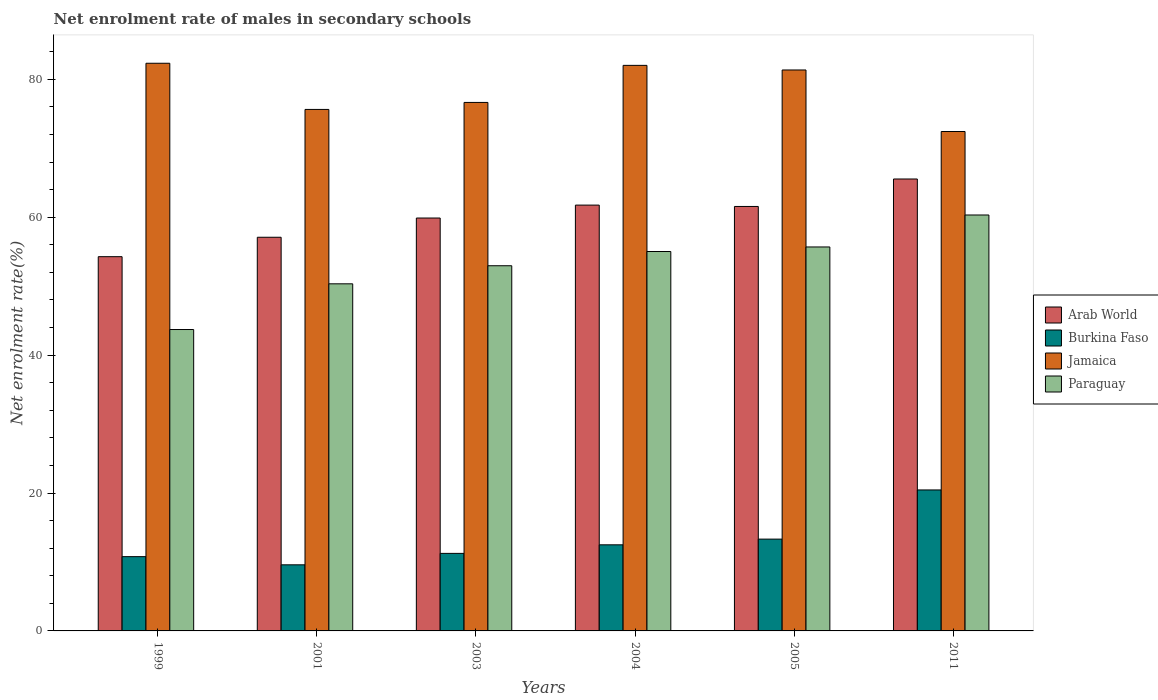Are the number of bars per tick equal to the number of legend labels?
Offer a very short reply. Yes. Are the number of bars on each tick of the X-axis equal?
Keep it short and to the point. Yes. How many bars are there on the 2nd tick from the right?
Ensure brevity in your answer.  4. What is the label of the 6th group of bars from the left?
Your answer should be very brief. 2011. What is the net enrolment rate of males in secondary schools in Burkina Faso in 2011?
Your response must be concise. 20.45. Across all years, what is the maximum net enrolment rate of males in secondary schools in Burkina Faso?
Your answer should be compact. 20.45. Across all years, what is the minimum net enrolment rate of males in secondary schools in Arab World?
Provide a short and direct response. 54.28. In which year was the net enrolment rate of males in secondary schools in Arab World minimum?
Provide a succinct answer. 1999. What is the total net enrolment rate of males in secondary schools in Arab World in the graph?
Your answer should be very brief. 360.13. What is the difference between the net enrolment rate of males in secondary schools in Paraguay in 2003 and that in 2004?
Keep it short and to the point. -2.06. What is the difference between the net enrolment rate of males in secondary schools in Burkina Faso in 2005 and the net enrolment rate of males in secondary schools in Arab World in 1999?
Offer a very short reply. -40.96. What is the average net enrolment rate of males in secondary schools in Arab World per year?
Offer a very short reply. 60.02. In the year 2001, what is the difference between the net enrolment rate of males in secondary schools in Arab World and net enrolment rate of males in secondary schools in Paraguay?
Your answer should be very brief. 6.75. In how many years, is the net enrolment rate of males in secondary schools in Paraguay greater than 36 %?
Your answer should be very brief. 6. What is the ratio of the net enrolment rate of males in secondary schools in Arab World in 2001 to that in 2011?
Provide a succinct answer. 0.87. Is the net enrolment rate of males in secondary schools in Paraguay in 2003 less than that in 2004?
Offer a terse response. Yes. What is the difference between the highest and the second highest net enrolment rate of males in secondary schools in Arab World?
Make the answer very short. 3.79. What is the difference between the highest and the lowest net enrolment rate of males in secondary schools in Jamaica?
Provide a succinct answer. 9.9. What does the 1st bar from the left in 2004 represents?
Provide a succinct answer. Arab World. What does the 1st bar from the right in 1999 represents?
Your response must be concise. Paraguay. How many years are there in the graph?
Give a very brief answer. 6. Where does the legend appear in the graph?
Provide a succinct answer. Center right. How are the legend labels stacked?
Make the answer very short. Vertical. What is the title of the graph?
Give a very brief answer. Net enrolment rate of males in secondary schools. What is the label or title of the X-axis?
Offer a terse response. Years. What is the label or title of the Y-axis?
Make the answer very short. Net enrolment rate(%). What is the Net enrolment rate(%) of Arab World in 1999?
Ensure brevity in your answer.  54.28. What is the Net enrolment rate(%) in Burkina Faso in 1999?
Your answer should be very brief. 10.77. What is the Net enrolment rate(%) in Jamaica in 1999?
Make the answer very short. 82.33. What is the Net enrolment rate(%) in Paraguay in 1999?
Keep it short and to the point. 43.71. What is the Net enrolment rate(%) of Arab World in 2001?
Your response must be concise. 57.1. What is the Net enrolment rate(%) in Burkina Faso in 2001?
Offer a terse response. 9.59. What is the Net enrolment rate(%) in Jamaica in 2001?
Your answer should be very brief. 75.63. What is the Net enrolment rate(%) of Paraguay in 2001?
Your response must be concise. 50.34. What is the Net enrolment rate(%) of Arab World in 2003?
Provide a succinct answer. 59.89. What is the Net enrolment rate(%) in Burkina Faso in 2003?
Provide a succinct answer. 11.25. What is the Net enrolment rate(%) of Jamaica in 2003?
Keep it short and to the point. 76.65. What is the Net enrolment rate(%) in Paraguay in 2003?
Give a very brief answer. 52.96. What is the Net enrolment rate(%) of Arab World in 2004?
Give a very brief answer. 61.76. What is the Net enrolment rate(%) in Burkina Faso in 2004?
Make the answer very short. 12.49. What is the Net enrolment rate(%) in Jamaica in 2004?
Give a very brief answer. 82.03. What is the Net enrolment rate(%) in Paraguay in 2004?
Your response must be concise. 55.03. What is the Net enrolment rate(%) of Arab World in 2005?
Ensure brevity in your answer.  61.56. What is the Net enrolment rate(%) in Burkina Faso in 2005?
Provide a short and direct response. 13.31. What is the Net enrolment rate(%) of Jamaica in 2005?
Make the answer very short. 81.36. What is the Net enrolment rate(%) of Paraguay in 2005?
Your answer should be very brief. 55.69. What is the Net enrolment rate(%) of Arab World in 2011?
Ensure brevity in your answer.  65.55. What is the Net enrolment rate(%) in Burkina Faso in 2011?
Your response must be concise. 20.45. What is the Net enrolment rate(%) of Jamaica in 2011?
Keep it short and to the point. 72.43. What is the Net enrolment rate(%) in Paraguay in 2011?
Provide a succinct answer. 60.33. Across all years, what is the maximum Net enrolment rate(%) of Arab World?
Ensure brevity in your answer.  65.55. Across all years, what is the maximum Net enrolment rate(%) in Burkina Faso?
Your answer should be compact. 20.45. Across all years, what is the maximum Net enrolment rate(%) in Jamaica?
Keep it short and to the point. 82.33. Across all years, what is the maximum Net enrolment rate(%) of Paraguay?
Give a very brief answer. 60.33. Across all years, what is the minimum Net enrolment rate(%) of Arab World?
Your answer should be very brief. 54.28. Across all years, what is the minimum Net enrolment rate(%) in Burkina Faso?
Your answer should be very brief. 9.59. Across all years, what is the minimum Net enrolment rate(%) of Jamaica?
Ensure brevity in your answer.  72.43. Across all years, what is the minimum Net enrolment rate(%) in Paraguay?
Give a very brief answer. 43.71. What is the total Net enrolment rate(%) in Arab World in the graph?
Offer a terse response. 360.13. What is the total Net enrolment rate(%) in Burkina Faso in the graph?
Keep it short and to the point. 77.85. What is the total Net enrolment rate(%) in Jamaica in the graph?
Ensure brevity in your answer.  470.44. What is the total Net enrolment rate(%) in Paraguay in the graph?
Provide a short and direct response. 318.06. What is the difference between the Net enrolment rate(%) in Arab World in 1999 and that in 2001?
Ensure brevity in your answer.  -2.82. What is the difference between the Net enrolment rate(%) in Burkina Faso in 1999 and that in 2001?
Keep it short and to the point. 1.19. What is the difference between the Net enrolment rate(%) of Jamaica in 1999 and that in 2001?
Provide a succinct answer. 6.7. What is the difference between the Net enrolment rate(%) in Paraguay in 1999 and that in 2001?
Ensure brevity in your answer.  -6.63. What is the difference between the Net enrolment rate(%) of Arab World in 1999 and that in 2003?
Your response must be concise. -5.61. What is the difference between the Net enrolment rate(%) of Burkina Faso in 1999 and that in 2003?
Give a very brief answer. -0.47. What is the difference between the Net enrolment rate(%) in Jamaica in 1999 and that in 2003?
Your answer should be compact. 5.68. What is the difference between the Net enrolment rate(%) of Paraguay in 1999 and that in 2003?
Provide a short and direct response. -9.25. What is the difference between the Net enrolment rate(%) in Arab World in 1999 and that in 2004?
Your response must be concise. -7.48. What is the difference between the Net enrolment rate(%) of Burkina Faso in 1999 and that in 2004?
Give a very brief answer. -1.71. What is the difference between the Net enrolment rate(%) of Jamaica in 1999 and that in 2004?
Ensure brevity in your answer.  0.31. What is the difference between the Net enrolment rate(%) in Paraguay in 1999 and that in 2004?
Ensure brevity in your answer.  -11.32. What is the difference between the Net enrolment rate(%) of Arab World in 1999 and that in 2005?
Make the answer very short. -7.28. What is the difference between the Net enrolment rate(%) in Burkina Faso in 1999 and that in 2005?
Give a very brief answer. -2.54. What is the difference between the Net enrolment rate(%) in Jamaica in 1999 and that in 2005?
Make the answer very short. 0.97. What is the difference between the Net enrolment rate(%) in Paraguay in 1999 and that in 2005?
Your answer should be compact. -11.98. What is the difference between the Net enrolment rate(%) of Arab World in 1999 and that in 2011?
Offer a very short reply. -11.27. What is the difference between the Net enrolment rate(%) of Burkina Faso in 1999 and that in 2011?
Provide a short and direct response. -9.67. What is the difference between the Net enrolment rate(%) in Jamaica in 1999 and that in 2011?
Give a very brief answer. 9.9. What is the difference between the Net enrolment rate(%) of Paraguay in 1999 and that in 2011?
Offer a terse response. -16.61. What is the difference between the Net enrolment rate(%) in Arab World in 2001 and that in 2003?
Provide a succinct answer. -2.79. What is the difference between the Net enrolment rate(%) of Burkina Faso in 2001 and that in 2003?
Keep it short and to the point. -1.66. What is the difference between the Net enrolment rate(%) in Jamaica in 2001 and that in 2003?
Make the answer very short. -1.02. What is the difference between the Net enrolment rate(%) of Paraguay in 2001 and that in 2003?
Your answer should be very brief. -2.62. What is the difference between the Net enrolment rate(%) of Arab World in 2001 and that in 2004?
Your answer should be very brief. -4.66. What is the difference between the Net enrolment rate(%) of Burkina Faso in 2001 and that in 2004?
Offer a terse response. -2.9. What is the difference between the Net enrolment rate(%) of Jamaica in 2001 and that in 2004?
Keep it short and to the point. -6.39. What is the difference between the Net enrolment rate(%) of Paraguay in 2001 and that in 2004?
Your answer should be very brief. -4.69. What is the difference between the Net enrolment rate(%) of Arab World in 2001 and that in 2005?
Give a very brief answer. -4.47. What is the difference between the Net enrolment rate(%) of Burkina Faso in 2001 and that in 2005?
Provide a short and direct response. -3.73. What is the difference between the Net enrolment rate(%) in Jamaica in 2001 and that in 2005?
Offer a very short reply. -5.72. What is the difference between the Net enrolment rate(%) of Paraguay in 2001 and that in 2005?
Your response must be concise. -5.35. What is the difference between the Net enrolment rate(%) of Arab World in 2001 and that in 2011?
Your response must be concise. -8.45. What is the difference between the Net enrolment rate(%) of Burkina Faso in 2001 and that in 2011?
Offer a very short reply. -10.86. What is the difference between the Net enrolment rate(%) in Jamaica in 2001 and that in 2011?
Provide a short and direct response. 3.2. What is the difference between the Net enrolment rate(%) in Paraguay in 2001 and that in 2011?
Make the answer very short. -9.98. What is the difference between the Net enrolment rate(%) in Arab World in 2003 and that in 2004?
Make the answer very short. -1.87. What is the difference between the Net enrolment rate(%) of Burkina Faso in 2003 and that in 2004?
Make the answer very short. -1.24. What is the difference between the Net enrolment rate(%) of Jamaica in 2003 and that in 2004?
Keep it short and to the point. -5.38. What is the difference between the Net enrolment rate(%) in Paraguay in 2003 and that in 2004?
Ensure brevity in your answer.  -2.06. What is the difference between the Net enrolment rate(%) in Arab World in 2003 and that in 2005?
Provide a succinct answer. -1.68. What is the difference between the Net enrolment rate(%) in Burkina Faso in 2003 and that in 2005?
Ensure brevity in your answer.  -2.07. What is the difference between the Net enrolment rate(%) of Jamaica in 2003 and that in 2005?
Make the answer very short. -4.71. What is the difference between the Net enrolment rate(%) in Paraguay in 2003 and that in 2005?
Your answer should be compact. -2.72. What is the difference between the Net enrolment rate(%) in Arab World in 2003 and that in 2011?
Offer a terse response. -5.66. What is the difference between the Net enrolment rate(%) of Burkina Faso in 2003 and that in 2011?
Make the answer very short. -9.2. What is the difference between the Net enrolment rate(%) of Jamaica in 2003 and that in 2011?
Your response must be concise. 4.22. What is the difference between the Net enrolment rate(%) of Paraguay in 2003 and that in 2011?
Offer a terse response. -7.36. What is the difference between the Net enrolment rate(%) of Arab World in 2004 and that in 2005?
Your response must be concise. 0.2. What is the difference between the Net enrolment rate(%) in Burkina Faso in 2004 and that in 2005?
Offer a very short reply. -0.83. What is the difference between the Net enrolment rate(%) in Jamaica in 2004 and that in 2005?
Make the answer very short. 0.67. What is the difference between the Net enrolment rate(%) in Paraguay in 2004 and that in 2005?
Your response must be concise. -0.66. What is the difference between the Net enrolment rate(%) of Arab World in 2004 and that in 2011?
Provide a short and direct response. -3.79. What is the difference between the Net enrolment rate(%) in Burkina Faso in 2004 and that in 2011?
Provide a succinct answer. -7.96. What is the difference between the Net enrolment rate(%) in Jamaica in 2004 and that in 2011?
Keep it short and to the point. 9.59. What is the difference between the Net enrolment rate(%) of Paraguay in 2004 and that in 2011?
Offer a terse response. -5.3. What is the difference between the Net enrolment rate(%) in Arab World in 2005 and that in 2011?
Your response must be concise. -3.98. What is the difference between the Net enrolment rate(%) in Burkina Faso in 2005 and that in 2011?
Provide a succinct answer. -7.13. What is the difference between the Net enrolment rate(%) in Jamaica in 2005 and that in 2011?
Your response must be concise. 8.93. What is the difference between the Net enrolment rate(%) in Paraguay in 2005 and that in 2011?
Your answer should be very brief. -4.64. What is the difference between the Net enrolment rate(%) of Arab World in 1999 and the Net enrolment rate(%) of Burkina Faso in 2001?
Your answer should be very brief. 44.69. What is the difference between the Net enrolment rate(%) of Arab World in 1999 and the Net enrolment rate(%) of Jamaica in 2001?
Keep it short and to the point. -21.35. What is the difference between the Net enrolment rate(%) in Arab World in 1999 and the Net enrolment rate(%) in Paraguay in 2001?
Offer a very short reply. 3.94. What is the difference between the Net enrolment rate(%) in Burkina Faso in 1999 and the Net enrolment rate(%) in Jamaica in 2001?
Provide a succinct answer. -64.86. What is the difference between the Net enrolment rate(%) of Burkina Faso in 1999 and the Net enrolment rate(%) of Paraguay in 2001?
Offer a very short reply. -39.57. What is the difference between the Net enrolment rate(%) of Jamaica in 1999 and the Net enrolment rate(%) of Paraguay in 2001?
Offer a terse response. 31.99. What is the difference between the Net enrolment rate(%) of Arab World in 1999 and the Net enrolment rate(%) of Burkina Faso in 2003?
Your answer should be very brief. 43.03. What is the difference between the Net enrolment rate(%) of Arab World in 1999 and the Net enrolment rate(%) of Jamaica in 2003?
Give a very brief answer. -22.37. What is the difference between the Net enrolment rate(%) of Arab World in 1999 and the Net enrolment rate(%) of Paraguay in 2003?
Your answer should be very brief. 1.32. What is the difference between the Net enrolment rate(%) of Burkina Faso in 1999 and the Net enrolment rate(%) of Jamaica in 2003?
Your response must be concise. -65.88. What is the difference between the Net enrolment rate(%) of Burkina Faso in 1999 and the Net enrolment rate(%) of Paraguay in 2003?
Your response must be concise. -42.19. What is the difference between the Net enrolment rate(%) in Jamaica in 1999 and the Net enrolment rate(%) in Paraguay in 2003?
Give a very brief answer. 29.37. What is the difference between the Net enrolment rate(%) of Arab World in 1999 and the Net enrolment rate(%) of Burkina Faso in 2004?
Keep it short and to the point. 41.79. What is the difference between the Net enrolment rate(%) of Arab World in 1999 and the Net enrolment rate(%) of Jamaica in 2004?
Keep it short and to the point. -27.75. What is the difference between the Net enrolment rate(%) in Arab World in 1999 and the Net enrolment rate(%) in Paraguay in 2004?
Offer a terse response. -0.75. What is the difference between the Net enrolment rate(%) in Burkina Faso in 1999 and the Net enrolment rate(%) in Jamaica in 2004?
Offer a very short reply. -71.25. What is the difference between the Net enrolment rate(%) of Burkina Faso in 1999 and the Net enrolment rate(%) of Paraguay in 2004?
Give a very brief answer. -44.26. What is the difference between the Net enrolment rate(%) in Jamaica in 1999 and the Net enrolment rate(%) in Paraguay in 2004?
Your answer should be compact. 27.3. What is the difference between the Net enrolment rate(%) in Arab World in 1999 and the Net enrolment rate(%) in Burkina Faso in 2005?
Make the answer very short. 40.96. What is the difference between the Net enrolment rate(%) of Arab World in 1999 and the Net enrolment rate(%) of Jamaica in 2005?
Provide a succinct answer. -27.08. What is the difference between the Net enrolment rate(%) of Arab World in 1999 and the Net enrolment rate(%) of Paraguay in 2005?
Give a very brief answer. -1.41. What is the difference between the Net enrolment rate(%) in Burkina Faso in 1999 and the Net enrolment rate(%) in Jamaica in 2005?
Provide a short and direct response. -70.59. What is the difference between the Net enrolment rate(%) in Burkina Faso in 1999 and the Net enrolment rate(%) in Paraguay in 2005?
Provide a succinct answer. -44.92. What is the difference between the Net enrolment rate(%) of Jamaica in 1999 and the Net enrolment rate(%) of Paraguay in 2005?
Your answer should be compact. 26.64. What is the difference between the Net enrolment rate(%) of Arab World in 1999 and the Net enrolment rate(%) of Burkina Faso in 2011?
Give a very brief answer. 33.83. What is the difference between the Net enrolment rate(%) of Arab World in 1999 and the Net enrolment rate(%) of Jamaica in 2011?
Provide a short and direct response. -18.15. What is the difference between the Net enrolment rate(%) in Arab World in 1999 and the Net enrolment rate(%) in Paraguay in 2011?
Offer a very short reply. -6.05. What is the difference between the Net enrolment rate(%) of Burkina Faso in 1999 and the Net enrolment rate(%) of Jamaica in 2011?
Give a very brief answer. -61.66. What is the difference between the Net enrolment rate(%) of Burkina Faso in 1999 and the Net enrolment rate(%) of Paraguay in 2011?
Provide a succinct answer. -49.55. What is the difference between the Net enrolment rate(%) of Jamaica in 1999 and the Net enrolment rate(%) of Paraguay in 2011?
Offer a terse response. 22.01. What is the difference between the Net enrolment rate(%) in Arab World in 2001 and the Net enrolment rate(%) in Burkina Faso in 2003?
Your response must be concise. 45.85. What is the difference between the Net enrolment rate(%) in Arab World in 2001 and the Net enrolment rate(%) in Jamaica in 2003?
Give a very brief answer. -19.55. What is the difference between the Net enrolment rate(%) in Arab World in 2001 and the Net enrolment rate(%) in Paraguay in 2003?
Ensure brevity in your answer.  4.13. What is the difference between the Net enrolment rate(%) in Burkina Faso in 2001 and the Net enrolment rate(%) in Jamaica in 2003?
Make the answer very short. -67.06. What is the difference between the Net enrolment rate(%) of Burkina Faso in 2001 and the Net enrolment rate(%) of Paraguay in 2003?
Ensure brevity in your answer.  -43.38. What is the difference between the Net enrolment rate(%) of Jamaica in 2001 and the Net enrolment rate(%) of Paraguay in 2003?
Offer a very short reply. 22.67. What is the difference between the Net enrolment rate(%) in Arab World in 2001 and the Net enrolment rate(%) in Burkina Faso in 2004?
Make the answer very short. 44.61. What is the difference between the Net enrolment rate(%) of Arab World in 2001 and the Net enrolment rate(%) of Jamaica in 2004?
Offer a very short reply. -24.93. What is the difference between the Net enrolment rate(%) of Arab World in 2001 and the Net enrolment rate(%) of Paraguay in 2004?
Provide a succinct answer. 2.07. What is the difference between the Net enrolment rate(%) of Burkina Faso in 2001 and the Net enrolment rate(%) of Jamaica in 2004?
Offer a very short reply. -72.44. What is the difference between the Net enrolment rate(%) of Burkina Faso in 2001 and the Net enrolment rate(%) of Paraguay in 2004?
Your answer should be compact. -45.44. What is the difference between the Net enrolment rate(%) of Jamaica in 2001 and the Net enrolment rate(%) of Paraguay in 2004?
Ensure brevity in your answer.  20.61. What is the difference between the Net enrolment rate(%) in Arab World in 2001 and the Net enrolment rate(%) in Burkina Faso in 2005?
Your answer should be compact. 43.78. What is the difference between the Net enrolment rate(%) in Arab World in 2001 and the Net enrolment rate(%) in Jamaica in 2005?
Your answer should be very brief. -24.26. What is the difference between the Net enrolment rate(%) in Arab World in 2001 and the Net enrolment rate(%) in Paraguay in 2005?
Keep it short and to the point. 1.41. What is the difference between the Net enrolment rate(%) in Burkina Faso in 2001 and the Net enrolment rate(%) in Jamaica in 2005?
Provide a short and direct response. -71.77. What is the difference between the Net enrolment rate(%) of Burkina Faso in 2001 and the Net enrolment rate(%) of Paraguay in 2005?
Make the answer very short. -46.1. What is the difference between the Net enrolment rate(%) of Jamaica in 2001 and the Net enrolment rate(%) of Paraguay in 2005?
Offer a very short reply. 19.95. What is the difference between the Net enrolment rate(%) in Arab World in 2001 and the Net enrolment rate(%) in Burkina Faso in 2011?
Ensure brevity in your answer.  36.65. What is the difference between the Net enrolment rate(%) of Arab World in 2001 and the Net enrolment rate(%) of Jamaica in 2011?
Make the answer very short. -15.34. What is the difference between the Net enrolment rate(%) in Arab World in 2001 and the Net enrolment rate(%) in Paraguay in 2011?
Offer a very short reply. -3.23. What is the difference between the Net enrolment rate(%) in Burkina Faso in 2001 and the Net enrolment rate(%) in Jamaica in 2011?
Give a very brief answer. -62.85. What is the difference between the Net enrolment rate(%) of Burkina Faso in 2001 and the Net enrolment rate(%) of Paraguay in 2011?
Offer a terse response. -50.74. What is the difference between the Net enrolment rate(%) in Jamaica in 2001 and the Net enrolment rate(%) in Paraguay in 2011?
Ensure brevity in your answer.  15.31. What is the difference between the Net enrolment rate(%) in Arab World in 2003 and the Net enrolment rate(%) in Burkina Faso in 2004?
Give a very brief answer. 47.4. What is the difference between the Net enrolment rate(%) in Arab World in 2003 and the Net enrolment rate(%) in Jamaica in 2004?
Keep it short and to the point. -22.14. What is the difference between the Net enrolment rate(%) in Arab World in 2003 and the Net enrolment rate(%) in Paraguay in 2004?
Make the answer very short. 4.86. What is the difference between the Net enrolment rate(%) of Burkina Faso in 2003 and the Net enrolment rate(%) of Jamaica in 2004?
Offer a very short reply. -70.78. What is the difference between the Net enrolment rate(%) of Burkina Faso in 2003 and the Net enrolment rate(%) of Paraguay in 2004?
Make the answer very short. -43.78. What is the difference between the Net enrolment rate(%) of Jamaica in 2003 and the Net enrolment rate(%) of Paraguay in 2004?
Offer a terse response. 21.62. What is the difference between the Net enrolment rate(%) of Arab World in 2003 and the Net enrolment rate(%) of Burkina Faso in 2005?
Your response must be concise. 46.57. What is the difference between the Net enrolment rate(%) of Arab World in 2003 and the Net enrolment rate(%) of Jamaica in 2005?
Ensure brevity in your answer.  -21.47. What is the difference between the Net enrolment rate(%) in Arab World in 2003 and the Net enrolment rate(%) in Paraguay in 2005?
Provide a succinct answer. 4.2. What is the difference between the Net enrolment rate(%) of Burkina Faso in 2003 and the Net enrolment rate(%) of Jamaica in 2005?
Keep it short and to the point. -70.11. What is the difference between the Net enrolment rate(%) in Burkina Faso in 2003 and the Net enrolment rate(%) in Paraguay in 2005?
Make the answer very short. -44.44. What is the difference between the Net enrolment rate(%) of Jamaica in 2003 and the Net enrolment rate(%) of Paraguay in 2005?
Provide a succinct answer. 20.96. What is the difference between the Net enrolment rate(%) of Arab World in 2003 and the Net enrolment rate(%) of Burkina Faso in 2011?
Offer a terse response. 39.44. What is the difference between the Net enrolment rate(%) in Arab World in 2003 and the Net enrolment rate(%) in Jamaica in 2011?
Ensure brevity in your answer.  -12.55. What is the difference between the Net enrolment rate(%) in Arab World in 2003 and the Net enrolment rate(%) in Paraguay in 2011?
Your response must be concise. -0.44. What is the difference between the Net enrolment rate(%) of Burkina Faso in 2003 and the Net enrolment rate(%) of Jamaica in 2011?
Provide a succinct answer. -61.19. What is the difference between the Net enrolment rate(%) of Burkina Faso in 2003 and the Net enrolment rate(%) of Paraguay in 2011?
Provide a short and direct response. -49.08. What is the difference between the Net enrolment rate(%) of Jamaica in 2003 and the Net enrolment rate(%) of Paraguay in 2011?
Provide a short and direct response. 16.33. What is the difference between the Net enrolment rate(%) in Arab World in 2004 and the Net enrolment rate(%) in Burkina Faso in 2005?
Provide a succinct answer. 48.44. What is the difference between the Net enrolment rate(%) in Arab World in 2004 and the Net enrolment rate(%) in Jamaica in 2005?
Keep it short and to the point. -19.6. What is the difference between the Net enrolment rate(%) in Arab World in 2004 and the Net enrolment rate(%) in Paraguay in 2005?
Provide a succinct answer. 6.07. What is the difference between the Net enrolment rate(%) in Burkina Faso in 2004 and the Net enrolment rate(%) in Jamaica in 2005?
Offer a very short reply. -68.87. What is the difference between the Net enrolment rate(%) in Burkina Faso in 2004 and the Net enrolment rate(%) in Paraguay in 2005?
Give a very brief answer. -43.2. What is the difference between the Net enrolment rate(%) in Jamaica in 2004 and the Net enrolment rate(%) in Paraguay in 2005?
Provide a succinct answer. 26.34. What is the difference between the Net enrolment rate(%) in Arab World in 2004 and the Net enrolment rate(%) in Burkina Faso in 2011?
Provide a short and direct response. 41.31. What is the difference between the Net enrolment rate(%) of Arab World in 2004 and the Net enrolment rate(%) of Jamaica in 2011?
Provide a succinct answer. -10.67. What is the difference between the Net enrolment rate(%) in Arab World in 2004 and the Net enrolment rate(%) in Paraguay in 2011?
Provide a short and direct response. 1.43. What is the difference between the Net enrolment rate(%) of Burkina Faso in 2004 and the Net enrolment rate(%) of Jamaica in 2011?
Keep it short and to the point. -59.95. What is the difference between the Net enrolment rate(%) in Burkina Faso in 2004 and the Net enrolment rate(%) in Paraguay in 2011?
Offer a terse response. -47.84. What is the difference between the Net enrolment rate(%) of Jamaica in 2004 and the Net enrolment rate(%) of Paraguay in 2011?
Your response must be concise. 21.7. What is the difference between the Net enrolment rate(%) in Arab World in 2005 and the Net enrolment rate(%) in Burkina Faso in 2011?
Keep it short and to the point. 41.12. What is the difference between the Net enrolment rate(%) in Arab World in 2005 and the Net enrolment rate(%) in Jamaica in 2011?
Offer a terse response. -10.87. What is the difference between the Net enrolment rate(%) of Arab World in 2005 and the Net enrolment rate(%) of Paraguay in 2011?
Your answer should be very brief. 1.24. What is the difference between the Net enrolment rate(%) of Burkina Faso in 2005 and the Net enrolment rate(%) of Jamaica in 2011?
Make the answer very short. -59.12. What is the difference between the Net enrolment rate(%) in Burkina Faso in 2005 and the Net enrolment rate(%) in Paraguay in 2011?
Your response must be concise. -47.01. What is the difference between the Net enrolment rate(%) of Jamaica in 2005 and the Net enrolment rate(%) of Paraguay in 2011?
Make the answer very short. 21.03. What is the average Net enrolment rate(%) in Arab World per year?
Your response must be concise. 60.02. What is the average Net enrolment rate(%) in Burkina Faso per year?
Offer a very short reply. 12.98. What is the average Net enrolment rate(%) in Jamaica per year?
Ensure brevity in your answer.  78.41. What is the average Net enrolment rate(%) in Paraguay per year?
Your answer should be compact. 53.01. In the year 1999, what is the difference between the Net enrolment rate(%) of Arab World and Net enrolment rate(%) of Burkina Faso?
Give a very brief answer. 43.51. In the year 1999, what is the difference between the Net enrolment rate(%) in Arab World and Net enrolment rate(%) in Jamaica?
Your response must be concise. -28.05. In the year 1999, what is the difference between the Net enrolment rate(%) of Arab World and Net enrolment rate(%) of Paraguay?
Your answer should be very brief. 10.57. In the year 1999, what is the difference between the Net enrolment rate(%) in Burkina Faso and Net enrolment rate(%) in Jamaica?
Your answer should be very brief. -71.56. In the year 1999, what is the difference between the Net enrolment rate(%) of Burkina Faso and Net enrolment rate(%) of Paraguay?
Ensure brevity in your answer.  -32.94. In the year 1999, what is the difference between the Net enrolment rate(%) of Jamaica and Net enrolment rate(%) of Paraguay?
Your answer should be very brief. 38.62. In the year 2001, what is the difference between the Net enrolment rate(%) in Arab World and Net enrolment rate(%) in Burkina Faso?
Ensure brevity in your answer.  47.51. In the year 2001, what is the difference between the Net enrolment rate(%) of Arab World and Net enrolment rate(%) of Jamaica?
Offer a terse response. -18.54. In the year 2001, what is the difference between the Net enrolment rate(%) of Arab World and Net enrolment rate(%) of Paraguay?
Your answer should be very brief. 6.75. In the year 2001, what is the difference between the Net enrolment rate(%) in Burkina Faso and Net enrolment rate(%) in Jamaica?
Provide a succinct answer. -66.05. In the year 2001, what is the difference between the Net enrolment rate(%) in Burkina Faso and Net enrolment rate(%) in Paraguay?
Ensure brevity in your answer.  -40.76. In the year 2001, what is the difference between the Net enrolment rate(%) of Jamaica and Net enrolment rate(%) of Paraguay?
Provide a short and direct response. 25.29. In the year 2003, what is the difference between the Net enrolment rate(%) in Arab World and Net enrolment rate(%) in Burkina Faso?
Your answer should be compact. 48.64. In the year 2003, what is the difference between the Net enrolment rate(%) in Arab World and Net enrolment rate(%) in Jamaica?
Your response must be concise. -16.77. In the year 2003, what is the difference between the Net enrolment rate(%) of Arab World and Net enrolment rate(%) of Paraguay?
Ensure brevity in your answer.  6.92. In the year 2003, what is the difference between the Net enrolment rate(%) in Burkina Faso and Net enrolment rate(%) in Jamaica?
Your answer should be compact. -65.41. In the year 2003, what is the difference between the Net enrolment rate(%) in Burkina Faso and Net enrolment rate(%) in Paraguay?
Your answer should be compact. -41.72. In the year 2003, what is the difference between the Net enrolment rate(%) in Jamaica and Net enrolment rate(%) in Paraguay?
Your answer should be compact. 23.69. In the year 2004, what is the difference between the Net enrolment rate(%) in Arab World and Net enrolment rate(%) in Burkina Faso?
Ensure brevity in your answer.  49.27. In the year 2004, what is the difference between the Net enrolment rate(%) of Arab World and Net enrolment rate(%) of Jamaica?
Ensure brevity in your answer.  -20.27. In the year 2004, what is the difference between the Net enrolment rate(%) in Arab World and Net enrolment rate(%) in Paraguay?
Provide a succinct answer. 6.73. In the year 2004, what is the difference between the Net enrolment rate(%) in Burkina Faso and Net enrolment rate(%) in Jamaica?
Ensure brevity in your answer.  -69.54. In the year 2004, what is the difference between the Net enrolment rate(%) in Burkina Faso and Net enrolment rate(%) in Paraguay?
Make the answer very short. -42.54. In the year 2004, what is the difference between the Net enrolment rate(%) in Jamaica and Net enrolment rate(%) in Paraguay?
Offer a very short reply. 27. In the year 2005, what is the difference between the Net enrolment rate(%) of Arab World and Net enrolment rate(%) of Burkina Faso?
Offer a terse response. 48.25. In the year 2005, what is the difference between the Net enrolment rate(%) in Arab World and Net enrolment rate(%) in Jamaica?
Make the answer very short. -19.8. In the year 2005, what is the difference between the Net enrolment rate(%) of Arab World and Net enrolment rate(%) of Paraguay?
Your answer should be compact. 5.87. In the year 2005, what is the difference between the Net enrolment rate(%) of Burkina Faso and Net enrolment rate(%) of Jamaica?
Keep it short and to the point. -68.04. In the year 2005, what is the difference between the Net enrolment rate(%) in Burkina Faso and Net enrolment rate(%) in Paraguay?
Provide a short and direct response. -42.37. In the year 2005, what is the difference between the Net enrolment rate(%) in Jamaica and Net enrolment rate(%) in Paraguay?
Offer a very short reply. 25.67. In the year 2011, what is the difference between the Net enrolment rate(%) of Arab World and Net enrolment rate(%) of Burkina Faso?
Your answer should be compact. 45.1. In the year 2011, what is the difference between the Net enrolment rate(%) in Arab World and Net enrolment rate(%) in Jamaica?
Your answer should be compact. -6.89. In the year 2011, what is the difference between the Net enrolment rate(%) in Arab World and Net enrolment rate(%) in Paraguay?
Provide a succinct answer. 5.22. In the year 2011, what is the difference between the Net enrolment rate(%) in Burkina Faso and Net enrolment rate(%) in Jamaica?
Your response must be concise. -51.99. In the year 2011, what is the difference between the Net enrolment rate(%) in Burkina Faso and Net enrolment rate(%) in Paraguay?
Offer a terse response. -39.88. In the year 2011, what is the difference between the Net enrolment rate(%) in Jamaica and Net enrolment rate(%) in Paraguay?
Ensure brevity in your answer.  12.11. What is the ratio of the Net enrolment rate(%) of Arab World in 1999 to that in 2001?
Offer a terse response. 0.95. What is the ratio of the Net enrolment rate(%) in Burkina Faso in 1999 to that in 2001?
Ensure brevity in your answer.  1.12. What is the ratio of the Net enrolment rate(%) in Jamaica in 1999 to that in 2001?
Your response must be concise. 1.09. What is the ratio of the Net enrolment rate(%) in Paraguay in 1999 to that in 2001?
Your answer should be very brief. 0.87. What is the ratio of the Net enrolment rate(%) of Arab World in 1999 to that in 2003?
Your answer should be very brief. 0.91. What is the ratio of the Net enrolment rate(%) of Burkina Faso in 1999 to that in 2003?
Your response must be concise. 0.96. What is the ratio of the Net enrolment rate(%) of Jamaica in 1999 to that in 2003?
Offer a very short reply. 1.07. What is the ratio of the Net enrolment rate(%) of Paraguay in 1999 to that in 2003?
Provide a short and direct response. 0.83. What is the ratio of the Net enrolment rate(%) of Arab World in 1999 to that in 2004?
Ensure brevity in your answer.  0.88. What is the ratio of the Net enrolment rate(%) in Burkina Faso in 1999 to that in 2004?
Offer a very short reply. 0.86. What is the ratio of the Net enrolment rate(%) in Paraguay in 1999 to that in 2004?
Give a very brief answer. 0.79. What is the ratio of the Net enrolment rate(%) in Arab World in 1999 to that in 2005?
Your answer should be compact. 0.88. What is the ratio of the Net enrolment rate(%) in Burkina Faso in 1999 to that in 2005?
Make the answer very short. 0.81. What is the ratio of the Net enrolment rate(%) in Jamaica in 1999 to that in 2005?
Give a very brief answer. 1.01. What is the ratio of the Net enrolment rate(%) in Paraguay in 1999 to that in 2005?
Your answer should be compact. 0.79. What is the ratio of the Net enrolment rate(%) in Arab World in 1999 to that in 2011?
Keep it short and to the point. 0.83. What is the ratio of the Net enrolment rate(%) in Burkina Faso in 1999 to that in 2011?
Keep it short and to the point. 0.53. What is the ratio of the Net enrolment rate(%) in Jamaica in 1999 to that in 2011?
Give a very brief answer. 1.14. What is the ratio of the Net enrolment rate(%) in Paraguay in 1999 to that in 2011?
Your answer should be very brief. 0.72. What is the ratio of the Net enrolment rate(%) in Arab World in 2001 to that in 2003?
Ensure brevity in your answer.  0.95. What is the ratio of the Net enrolment rate(%) of Burkina Faso in 2001 to that in 2003?
Ensure brevity in your answer.  0.85. What is the ratio of the Net enrolment rate(%) of Jamaica in 2001 to that in 2003?
Offer a terse response. 0.99. What is the ratio of the Net enrolment rate(%) of Paraguay in 2001 to that in 2003?
Offer a very short reply. 0.95. What is the ratio of the Net enrolment rate(%) in Arab World in 2001 to that in 2004?
Keep it short and to the point. 0.92. What is the ratio of the Net enrolment rate(%) in Burkina Faso in 2001 to that in 2004?
Provide a succinct answer. 0.77. What is the ratio of the Net enrolment rate(%) of Jamaica in 2001 to that in 2004?
Ensure brevity in your answer.  0.92. What is the ratio of the Net enrolment rate(%) of Paraguay in 2001 to that in 2004?
Keep it short and to the point. 0.91. What is the ratio of the Net enrolment rate(%) of Arab World in 2001 to that in 2005?
Your answer should be very brief. 0.93. What is the ratio of the Net enrolment rate(%) in Burkina Faso in 2001 to that in 2005?
Keep it short and to the point. 0.72. What is the ratio of the Net enrolment rate(%) in Jamaica in 2001 to that in 2005?
Provide a succinct answer. 0.93. What is the ratio of the Net enrolment rate(%) in Paraguay in 2001 to that in 2005?
Your response must be concise. 0.9. What is the ratio of the Net enrolment rate(%) in Arab World in 2001 to that in 2011?
Make the answer very short. 0.87. What is the ratio of the Net enrolment rate(%) in Burkina Faso in 2001 to that in 2011?
Your response must be concise. 0.47. What is the ratio of the Net enrolment rate(%) of Jamaica in 2001 to that in 2011?
Keep it short and to the point. 1.04. What is the ratio of the Net enrolment rate(%) in Paraguay in 2001 to that in 2011?
Offer a very short reply. 0.83. What is the ratio of the Net enrolment rate(%) of Arab World in 2003 to that in 2004?
Keep it short and to the point. 0.97. What is the ratio of the Net enrolment rate(%) in Burkina Faso in 2003 to that in 2004?
Your answer should be compact. 0.9. What is the ratio of the Net enrolment rate(%) of Jamaica in 2003 to that in 2004?
Give a very brief answer. 0.93. What is the ratio of the Net enrolment rate(%) in Paraguay in 2003 to that in 2004?
Offer a very short reply. 0.96. What is the ratio of the Net enrolment rate(%) of Arab World in 2003 to that in 2005?
Keep it short and to the point. 0.97. What is the ratio of the Net enrolment rate(%) of Burkina Faso in 2003 to that in 2005?
Your answer should be very brief. 0.84. What is the ratio of the Net enrolment rate(%) of Jamaica in 2003 to that in 2005?
Provide a short and direct response. 0.94. What is the ratio of the Net enrolment rate(%) in Paraguay in 2003 to that in 2005?
Offer a very short reply. 0.95. What is the ratio of the Net enrolment rate(%) in Arab World in 2003 to that in 2011?
Offer a very short reply. 0.91. What is the ratio of the Net enrolment rate(%) in Burkina Faso in 2003 to that in 2011?
Your answer should be compact. 0.55. What is the ratio of the Net enrolment rate(%) of Jamaica in 2003 to that in 2011?
Give a very brief answer. 1.06. What is the ratio of the Net enrolment rate(%) in Paraguay in 2003 to that in 2011?
Your answer should be compact. 0.88. What is the ratio of the Net enrolment rate(%) in Arab World in 2004 to that in 2005?
Your response must be concise. 1. What is the ratio of the Net enrolment rate(%) of Burkina Faso in 2004 to that in 2005?
Provide a short and direct response. 0.94. What is the ratio of the Net enrolment rate(%) in Jamaica in 2004 to that in 2005?
Give a very brief answer. 1.01. What is the ratio of the Net enrolment rate(%) in Paraguay in 2004 to that in 2005?
Make the answer very short. 0.99. What is the ratio of the Net enrolment rate(%) in Arab World in 2004 to that in 2011?
Your answer should be compact. 0.94. What is the ratio of the Net enrolment rate(%) in Burkina Faso in 2004 to that in 2011?
Keep it short and to the point. 0.61. What is the ratio of the Net enrolment rate(%) in Jamaica in 2004 to that in 2011?
Your answer should be compact. 1.13. What is the ratio of the Net enrolment rate(%) in Paraguay in 2004 to that in 2011?
Provide a short and direct response. 0.91. What is the ratio of the Net enrolment rate(%) in Arab World in 2005 to that in 2011?
Make the answer very short. 0.94. What is the ratio of the Net enrolment rate(%) in Burkina Faso in 2005 to that in 2011?
Your response must be concise. 0.65. What is the ratio of the Net enrolment rate(%) in Jamaica in 2005 to that in 2011?
Give a very brief answer. 1.12. What is the ratio of the Net enrolment rate(%) in Paraguay in 2005 to that in 2011?
Provide a succinct answer. 0.92. What is the difference between the highest and the second highest Net enrolment rate(%) in Arab World?
Your response must be concise. 3.79. What is the difference between the highest and the second highest Net enrolment rate(%) of Burkina Faso?
Provide a succinct answer. 7.13. What is the difference between the highest and the second highest Net enrolment rate(%) of Jamaica?
Offer a very short reply. 0.31. What is the difference between the highest and the second highest Net enrolment rate(%) of Paraguay?
Keep it short and to the point. 4.64. What is the difference between the highest and the lowest Net enrolment rate(%) of Arab World?
Offer a very short reply. 11.27. What is the difference between the highest and the lowest Net enrolment rate(%) in Burkina Faso?
Your response must be concise. 10.86. What is the difference between the highest and the lowest Net enrolment rate(%) of Jamaica?
Provide a short and direct response. 9.9. What is the difference between the highest and the lowest Net enrolment rate(%) in Paraguay?
Make the answer very short. 16.61. 